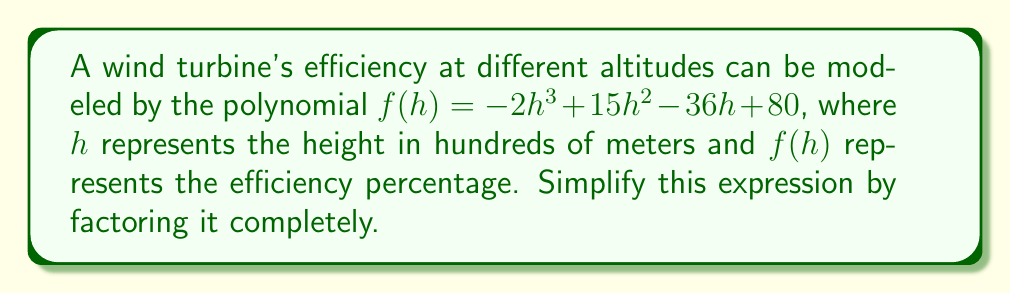Help me with this question. Let's approach this step-by-step:

1) First, we need to identify if there are any common factors. In this case, there are no common factors for all terms.

2) Next, we can try to factor by grouping. Let's split the polynomial into two groups:

   $f(h) = (-2h^3 + 15h^2) + (-36h + 80)$

3) Factor out the common factor from each group:

   $f(h) = h^2(-2h + 15) + (-36h + 80)$

4) Now, let's factor out $(h - 5)$ from $(-2h + 15)$:

   $f(h) = h^2(-(2h - 10)) + (-36h + 80)$
   $f(h) = -h^2(2h - 10) + (-36h + 80)$

5) Observe that $(2h - 10)$ is a factor of $(-36h + 80)$:

   $-36h + 80 = -4(2h - 10)$

6) So we can rewrite our expression as:

   $f(h) = -h^2(2h - 10) - 4(2h - 10)$

7) Now we can factor out $(2h - 10)$:

   $f(h) = -(h^2 + 4)(2h - 10)$

8) The quadratic term $(h^2 + 4)$ cannot be factored further as it has no real roots.

Therefore, the fully factored form is:

$$f(h) = -(h^2 + 4)(2h - 10)$$
Answer: $-(h^2 + 4)(2h - 10)$ 